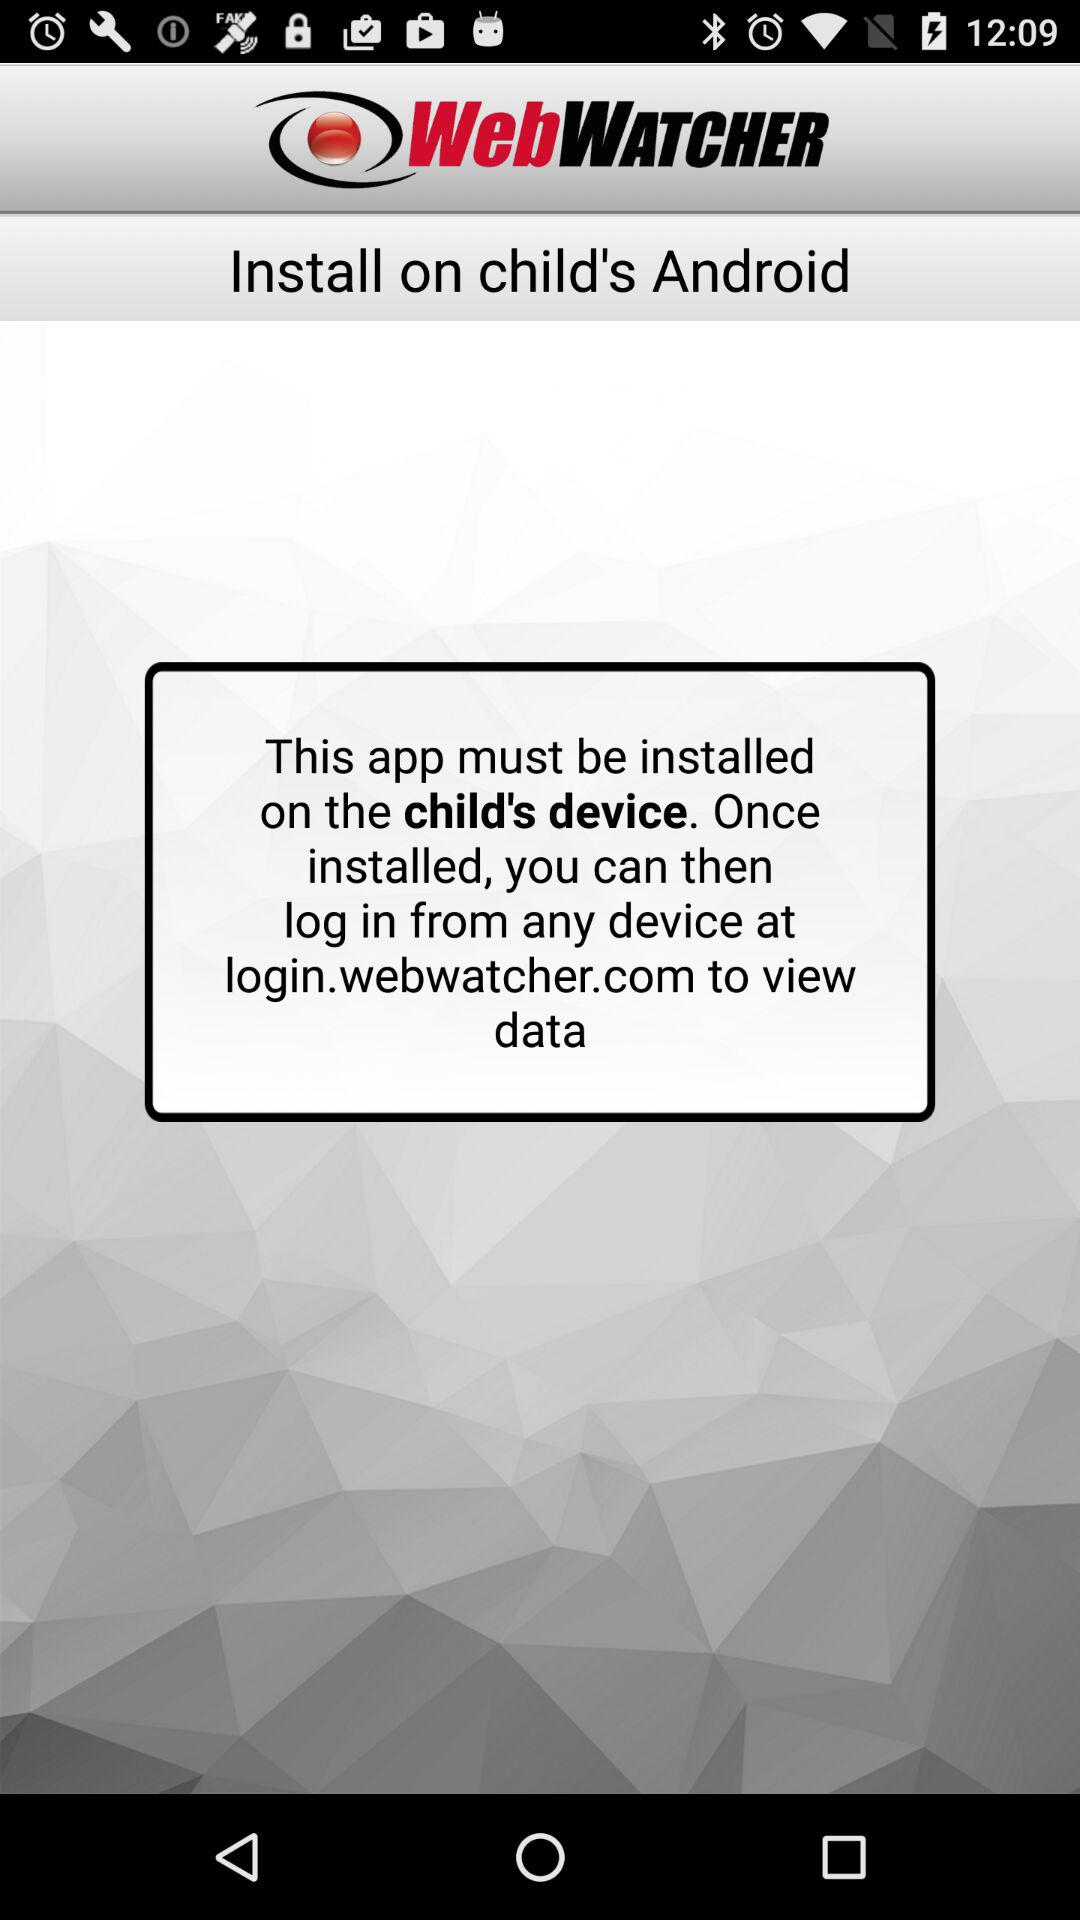Where can the application be installed? The application must be installed on the child's device. 